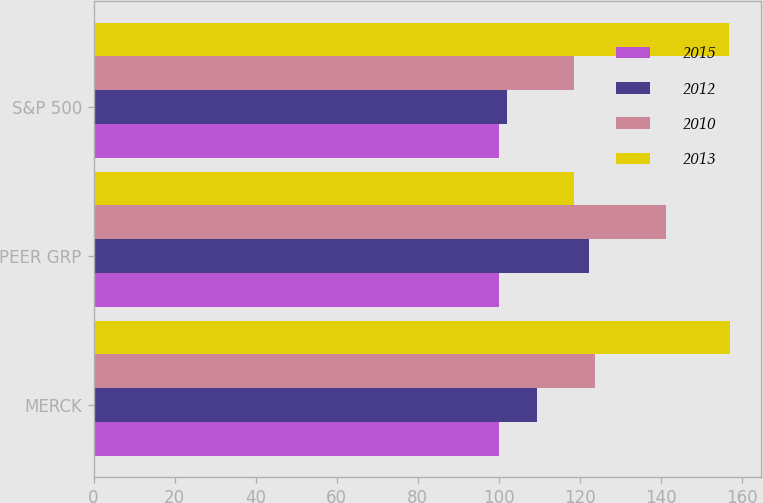Convert chart. <chart><loc_0><loc_0><loc_500><loc_500><stacked_bar_chart><ecel><fcel>MERCK<fcel>PEER GRP<fcel>S&P 500<nl><fcel>2015<fcel>100<fcel>100<fcel>100<nl><fcel>2012<fcel>109.4<fcel>122.23<fcel>102.1<nl><fcel>2010<fcel>123.72<fcel>141.2<fcel>118.44<nl><fcel>2013<fcel>156.9<fcel>118.44<fcel>156.78<nl></chart> 